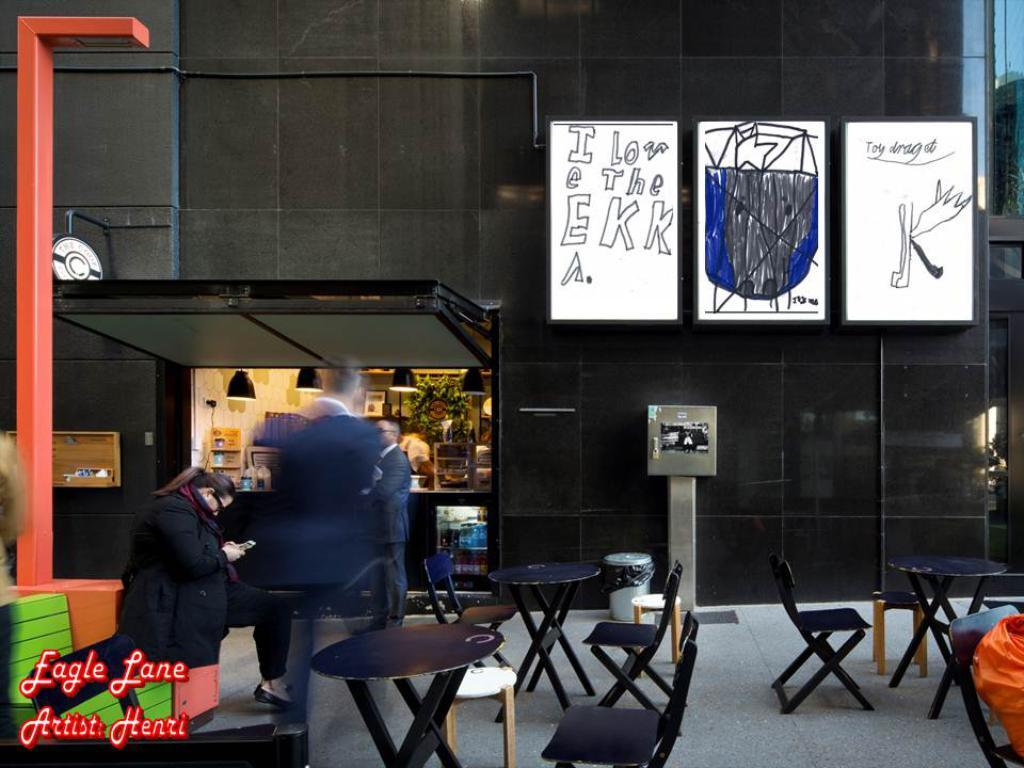What type of furniture is present in the image? There are chairs and tables in the image. What is used for writing or displaying information in the image? There are whiteboards in the image. What vertical structure can be seen in the image? There is a pole in the image. Can you describe any other objects in the image besides the ones mentioned? There are other unspecified objects in the image. What type of honey is being served on the tables in the image? There is no honey present in the image; it only features chairs, tables, whiteboards, and a pole. Can you see any chickens or monkeys in the image? No, there are no chickens or monkeys present in the image. 